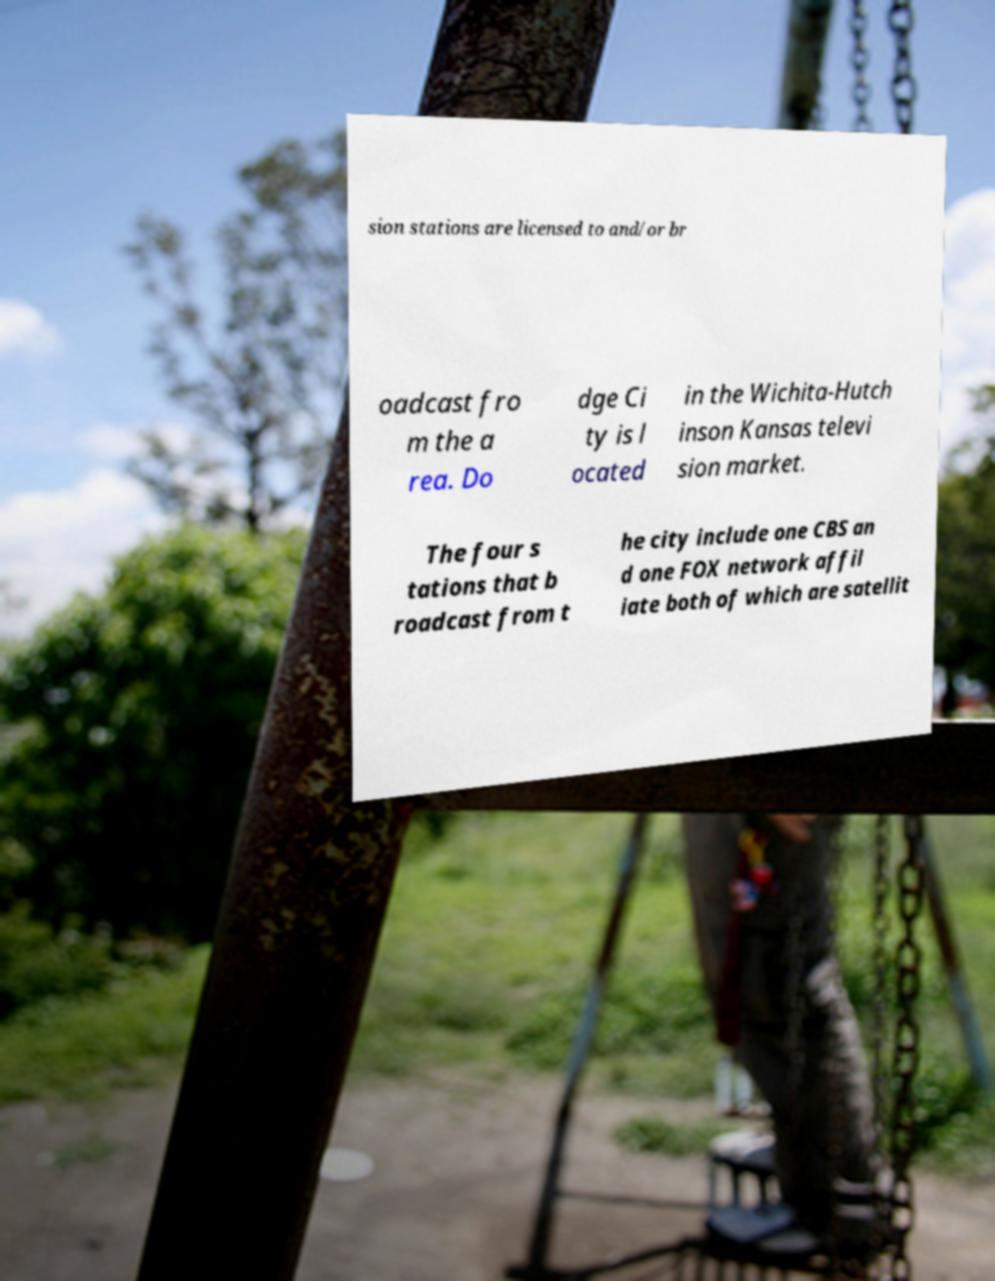For documentation purposes, I need the text within this image transcribed. Could you provide that? sion stations are licensed to and/or br oadcast fro m the a rea. Do dge Ci ty is l ocated in the Wichita-Hutch inson Kansas televi sion market. The four s tations that b roadcast from t he city include one CBS an d one FOX network affil iate both of which are satellit 